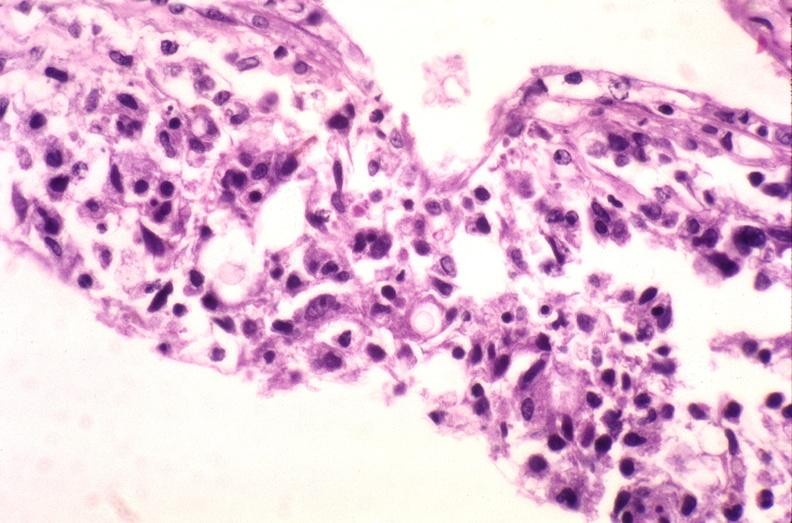what does this image show?
Answer the question using a single word or phrase. Brain 